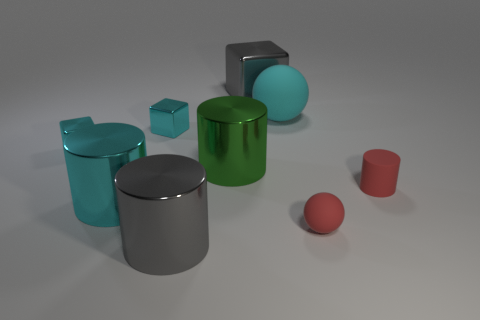How big is the metal cylinder that is on the right side of the gray shiny thing in front of the object that is behind the big cyan ball?
Keep it short and to the point. Large. The small object that is the same shape as the big rubber object is what color?
Ensure brevity in your answer.  Red. Is the number of gray shiny blocks behind the large block greater than the number of large gray shiny cubes?
Give a very brief answer. No. Do the large cyan matte object and the large cyan object that is in front of the small red rubber cylinder have the same shape?
Give a very brief answer. No. Are there any other things that are the same size as the cyan matte object?
Offer a very short reply. Yes. There is a rubber thing that is the same shape as the green shiny object; what is its size?
Ensure brevity in your answer.  Small. Is the number of matte objects greater than the number of yellow matte cylinders?
Make the answer very short. Yes. Do the large cyan metal object and the large green metallic thing have the same shape?
Offer a terse response. Yes. What is the material of the large gray object in front of the big cylinder that is on the right side of the gray metal cylinder?
Make the answer very short. Metal. There is another big object that is the same color as the big matte object; what is it made of?
Make the answer very short. Metal. 